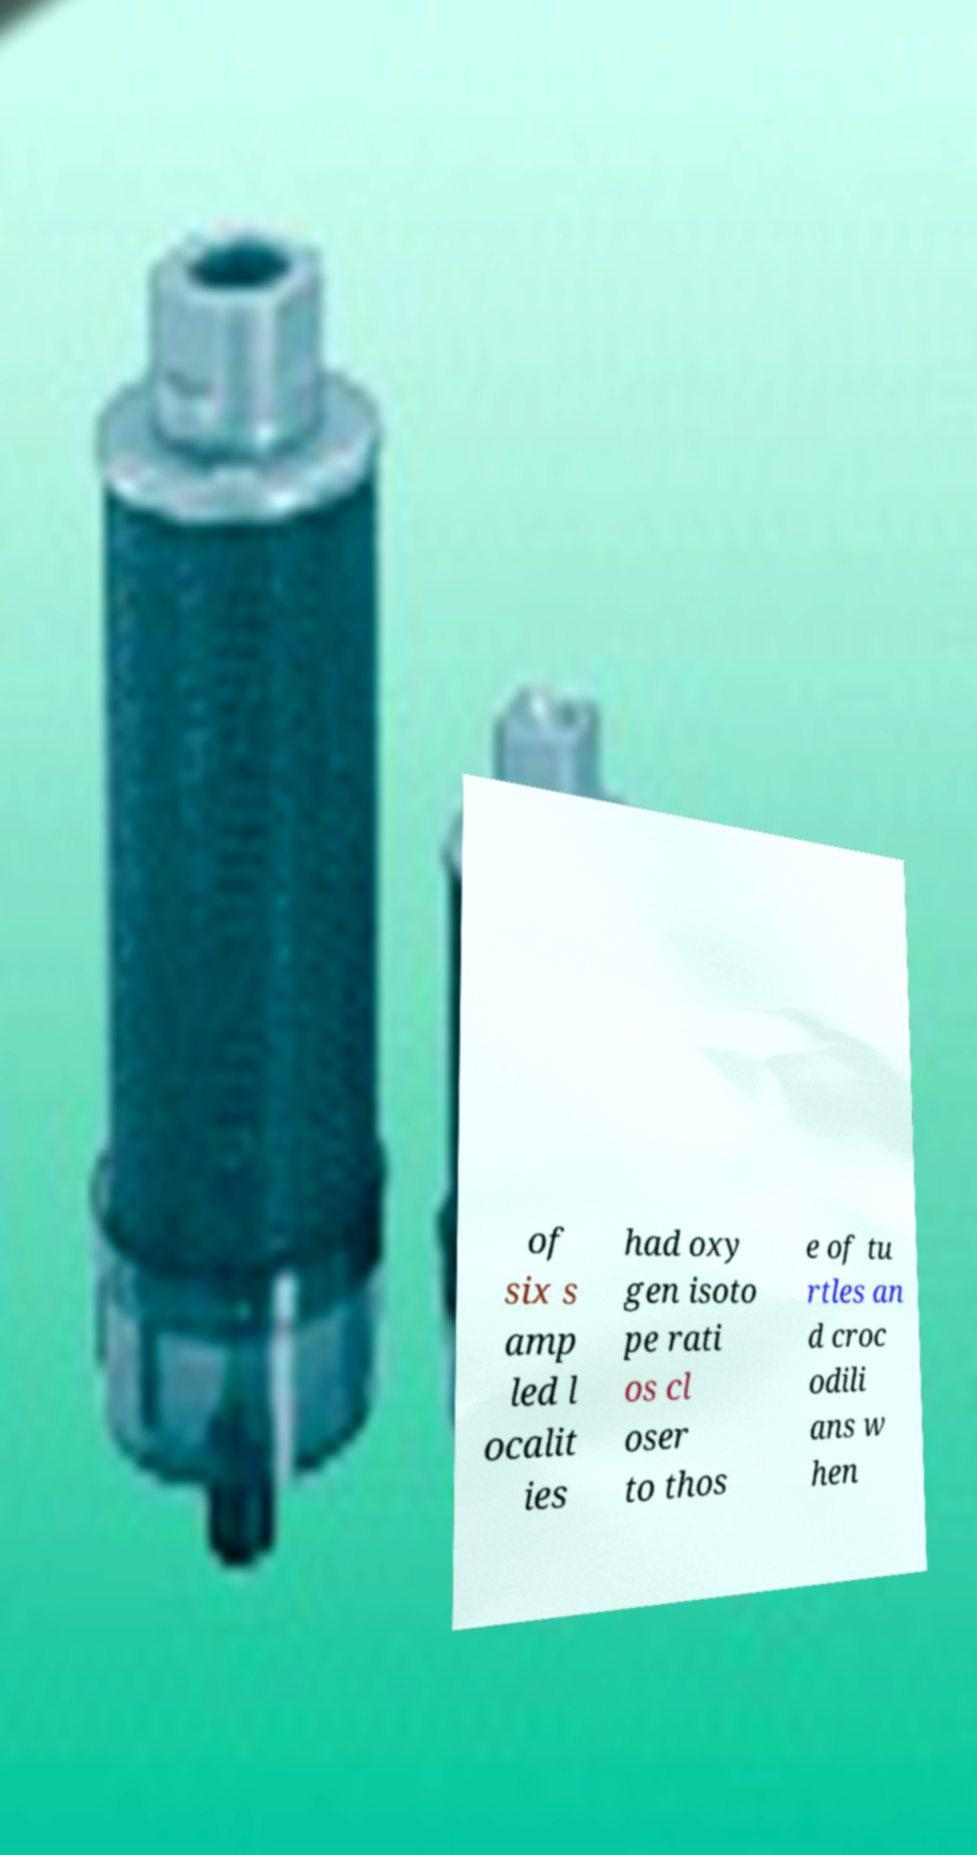Can you accurately transcribe the text from the provided image for me? of six s amp led l ocalit ies had oxy gen isoto pe rati os cl oser to thos e of tu rtles an d croc odili ans w hen 